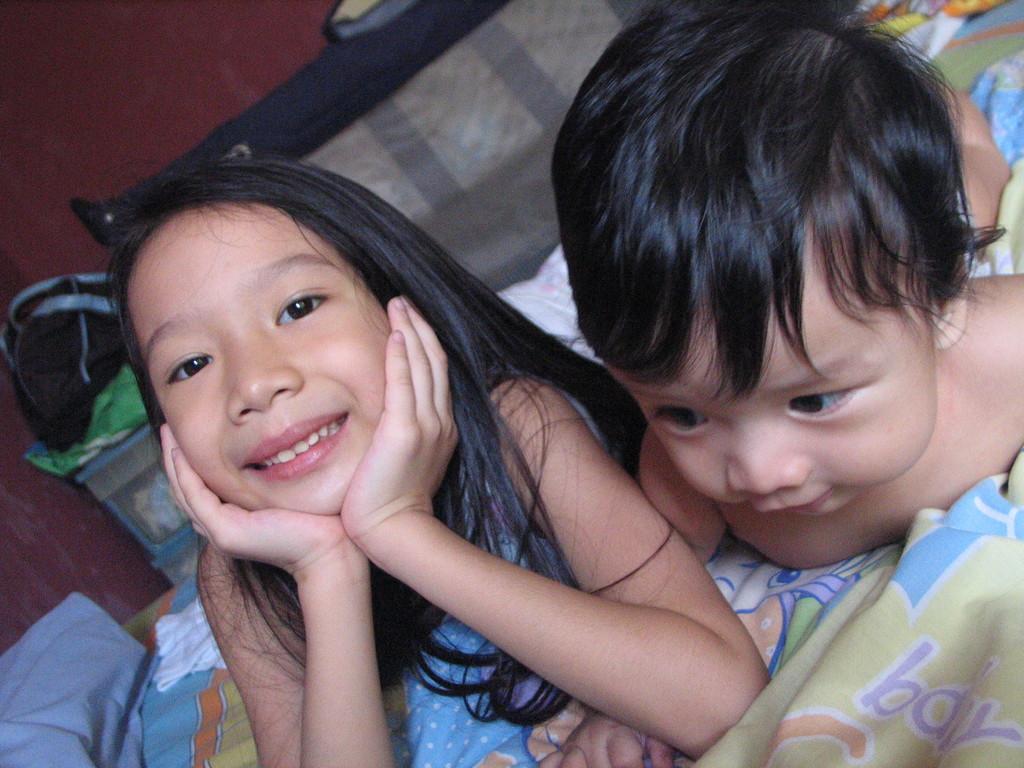Describe this image in one or two sentences. In this picture I can see a girl and a baby on the bed and I can see a wall in the background and looks like a bag on the left side of the picture 